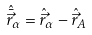Convert formula to latex. <formula><loc_0><loc_0><loc_500><loc_500>\hat { \bar { \vec { r } } } _ { \alpha } = \hat { \vec { r } } _ { \alpha } - \hat { \vec { r } } _ { A }</formula> 